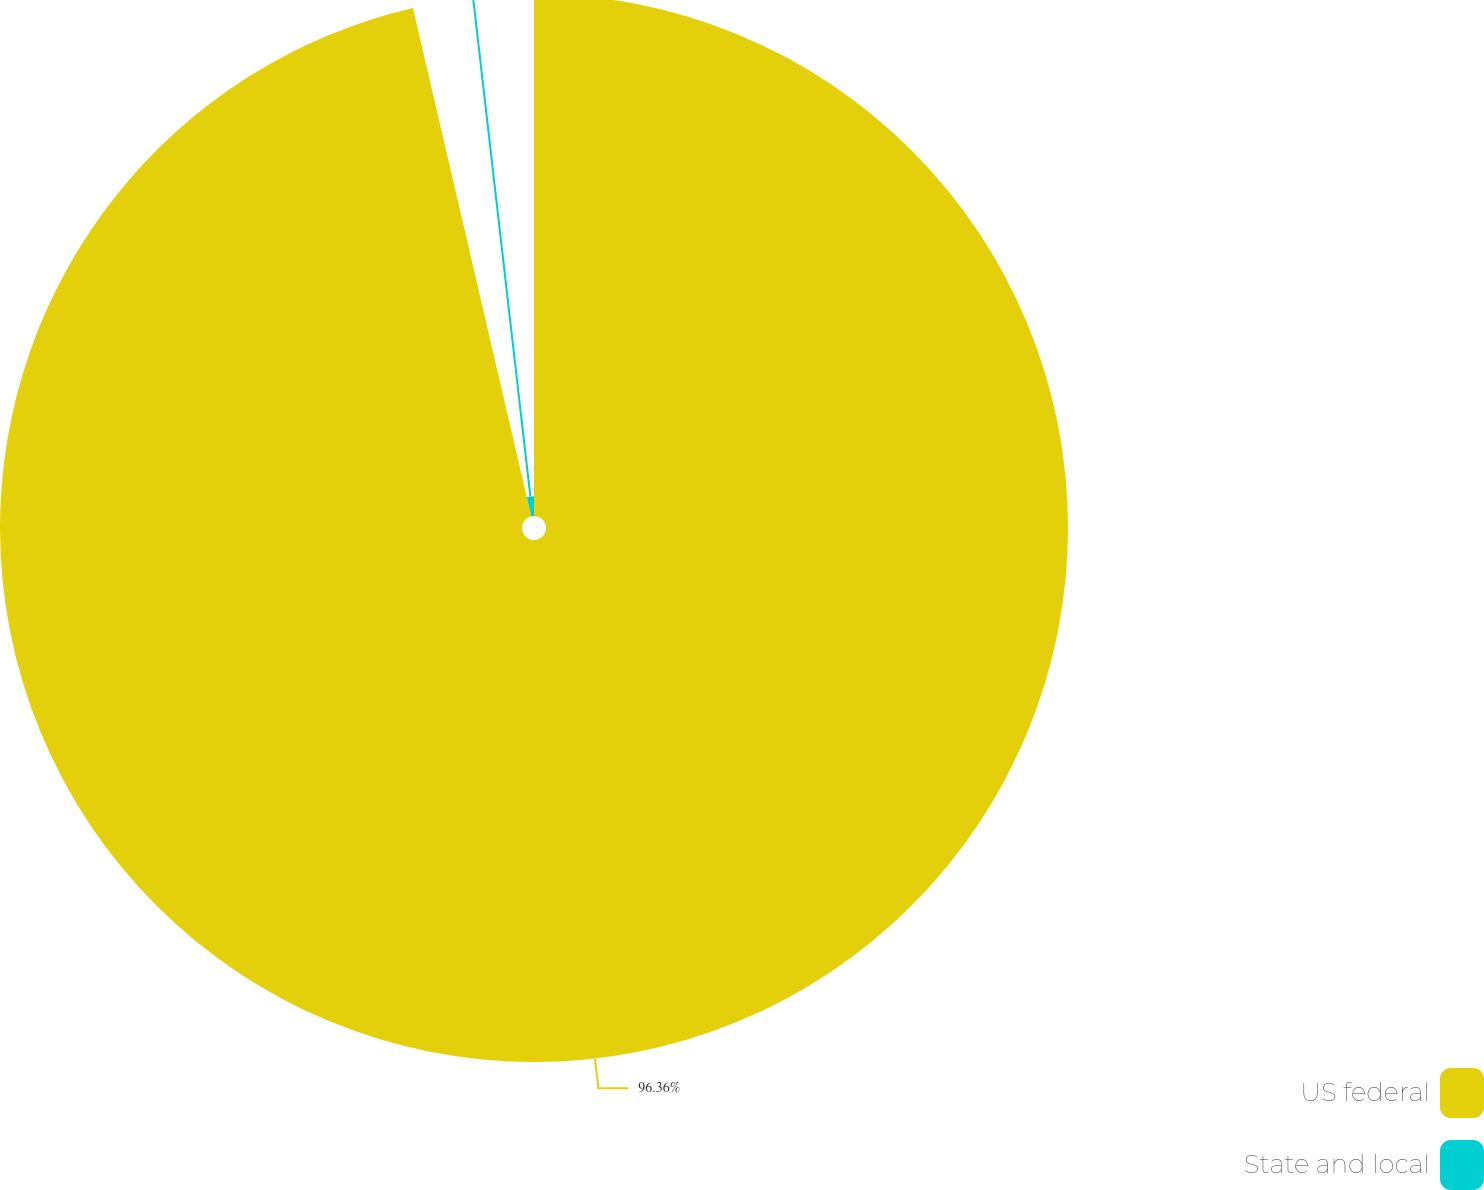Convert chart to OTSL. <chart><loc_0><loc_0><loc_500><loc_500><pie_chart><fcel>US federal<fcel>State and local<nl><fcel>96.36%<fcel>3.64%<nl></chart> 